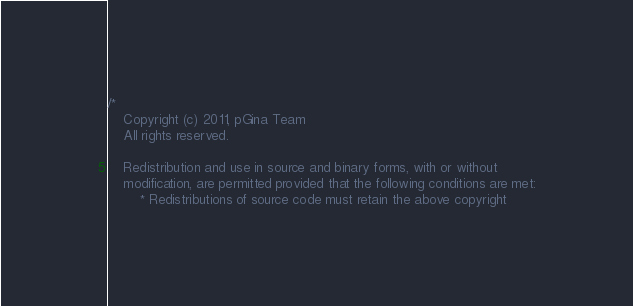Convert code to text. <code><loc_0><loc_0><loc_500><loc_500><_C++_>/*
	Copyright (c) 2011, pGina Team
	All rights reserved.

	Redistribution and use in source and binary forms, with or without
	modification, are permitted provided that the following conditions are met:
		* Redistributions of source code must retain the above copyright</code> 